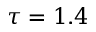Convert formula to latex. <formula><loc_0><loc_0><loc_500><loc_500>\tau = 1 . 4</formula> 